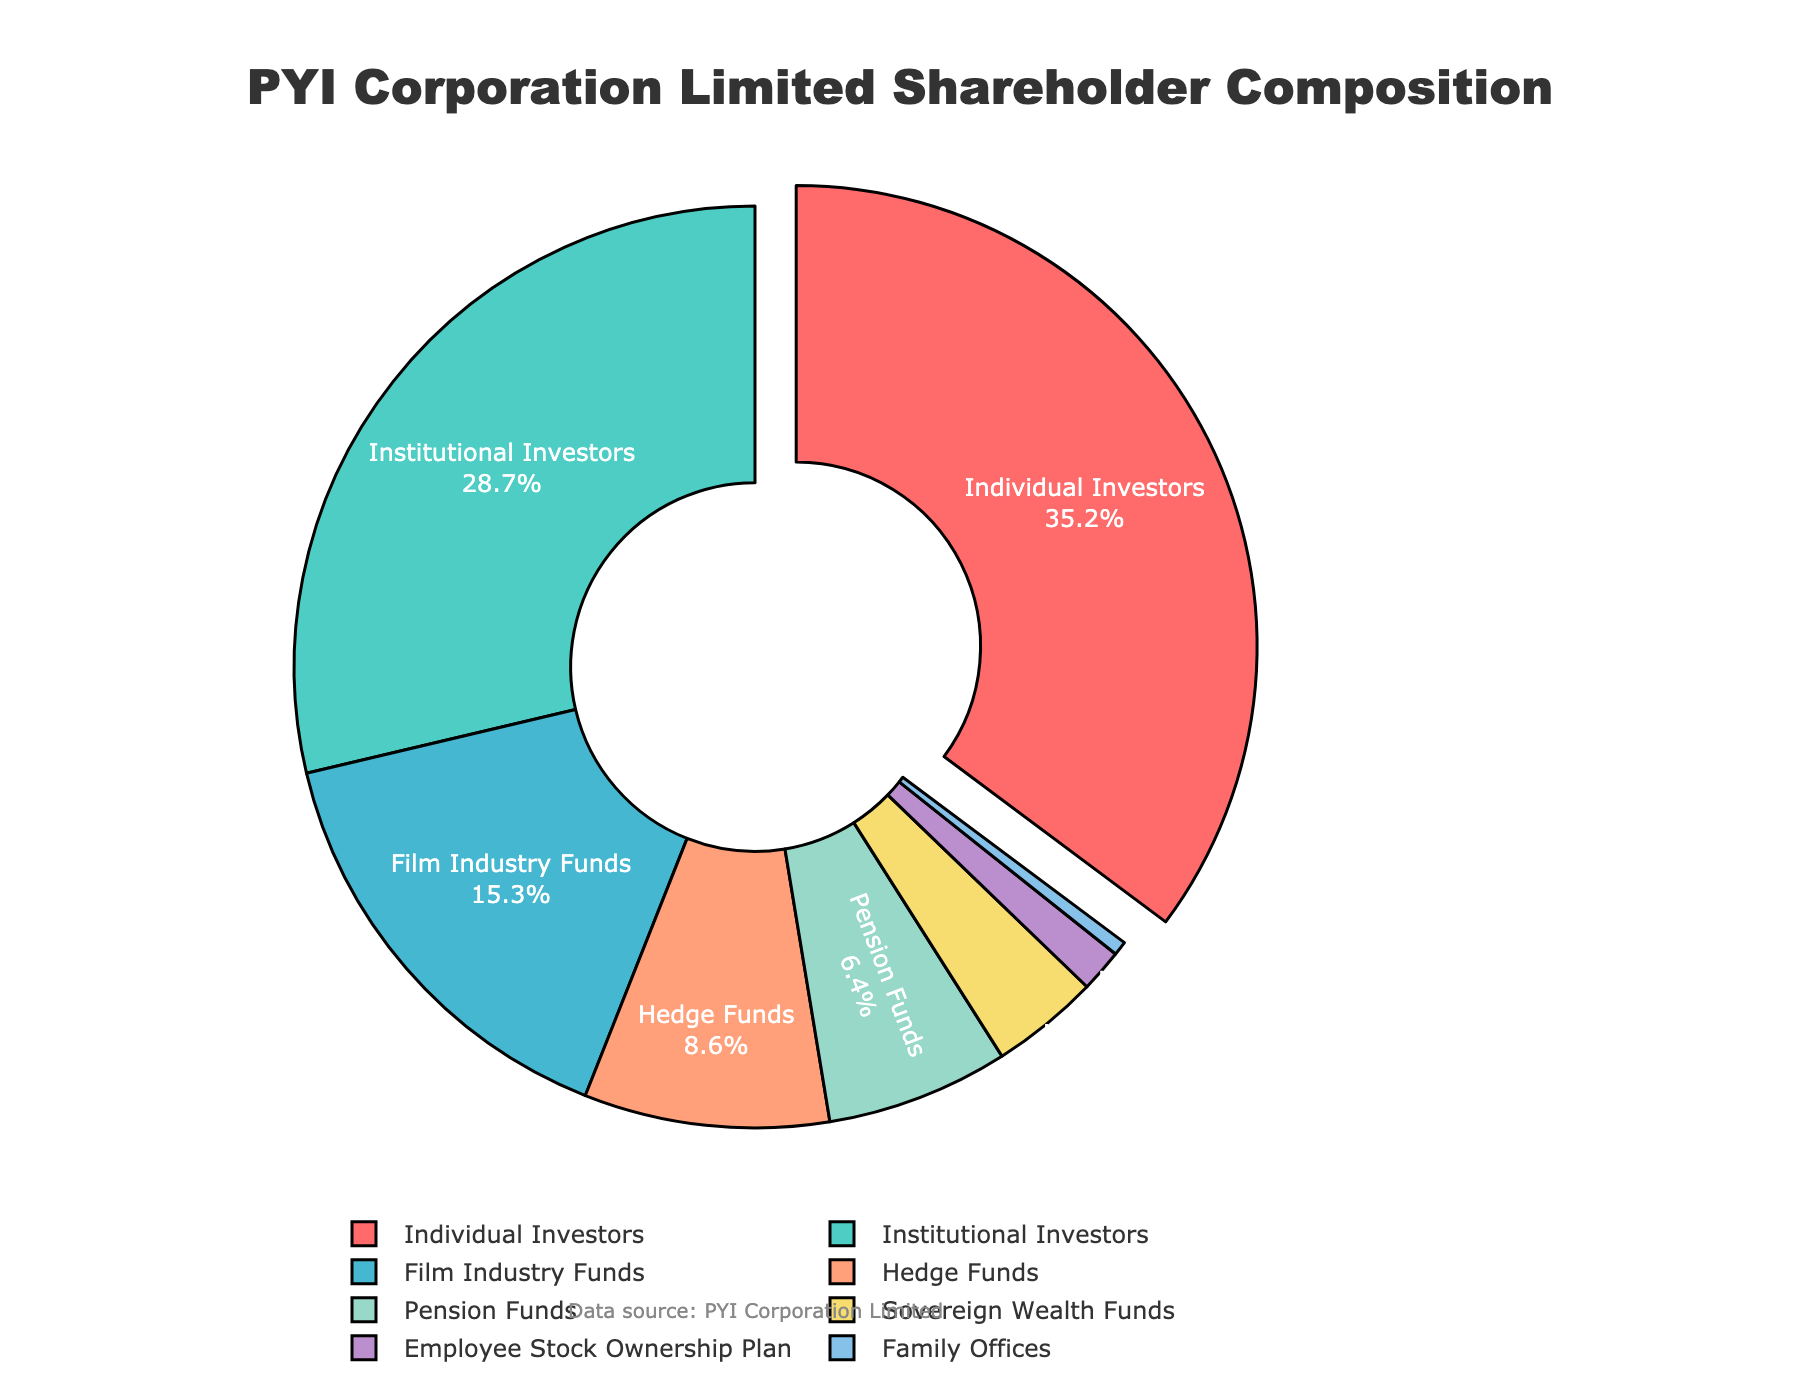What percentage of PYI Corporation Limited's shareholders are Family Offices and Sovereign Wealth Funds combined? To find the combined percentage of Family Offices and Sovereign Wealth Funds, add 0.5% (Family Offices) and 3.8% (Sovereign Wealth Funds) to get 4.3%.
Answer: 4.3% Which investor type holds the largest portion of shares, and what is that percentage? The pie chart visually emphasizes the largest segment by pulling it out. The largest segment represents Individual Investors, holding 35.2% of the shares.
Answer: Individual Investors, 35.2% By how much percentage do Individual Investors exceed Institutional Investors in PYI Corporation Limited's shareholder composition? Subtract the percentage of Institutional Investors (28.7%) from Individual Investors (35.2%), yielding a difference of 6.5%.
Answer: 6.5% Which two investor types have the smallest shareholder percentages, and what are their combined percentages? The smallest percentages on the pie chart are Family Offices (0.5%) and Employee Stock Ownership Plan (1.5%). Combined, they total 2.0%.
Answer: Family Offices and Employee Stock Ownership Plan, 2.0% Which investor types are represented by the warm colors (shades of red and orange), and what are their percentages? Examining the chart, the warm colors represent Individual Investors (35.2%), Hedge Funds (8.6%), and Film Industry Funds (15.3%).
Answer: Individual Investors, Hedge Funds, and Film Industry Funds; 35.2%, 8.6%, and 15.3% What is the total percentage of shareholders that are neither Individual Investors nor Institutional Investors? Subtract the percentages of Individual Investors (35.2%) and Institutional Investors (28.7%) from 100%. Calculation: 100% - (35.2% + 28.7%) = 36.1%.
Answer: 36.1% How does the percentage of Institutional Investors compare to the combined percentage of Pension Funds and Hedge Funds? Add the percentages of Pension Funds (6.4%) and Hedge Funds (8.6%) to get 15%. Institutional Investors alone comprise 28.7%, which is significantly higher.
Answer: Institutional Investors are higher Which type of investor is associated with the color '#45B7D1', and what is the investor's percentage? The color '#45B7D1' is associated with Film Industry Funds, which hold 15.3% of shares.
Answer: Film Industry Funds, 15.3% What proportion of the total shares are held by Hedge Funds and Film Industry Funds together? Combine the percentages of Hedge Funds (8.6%) and Film Industry Funds (15.3%) to get 23.9%.
Answer: 23.9% 